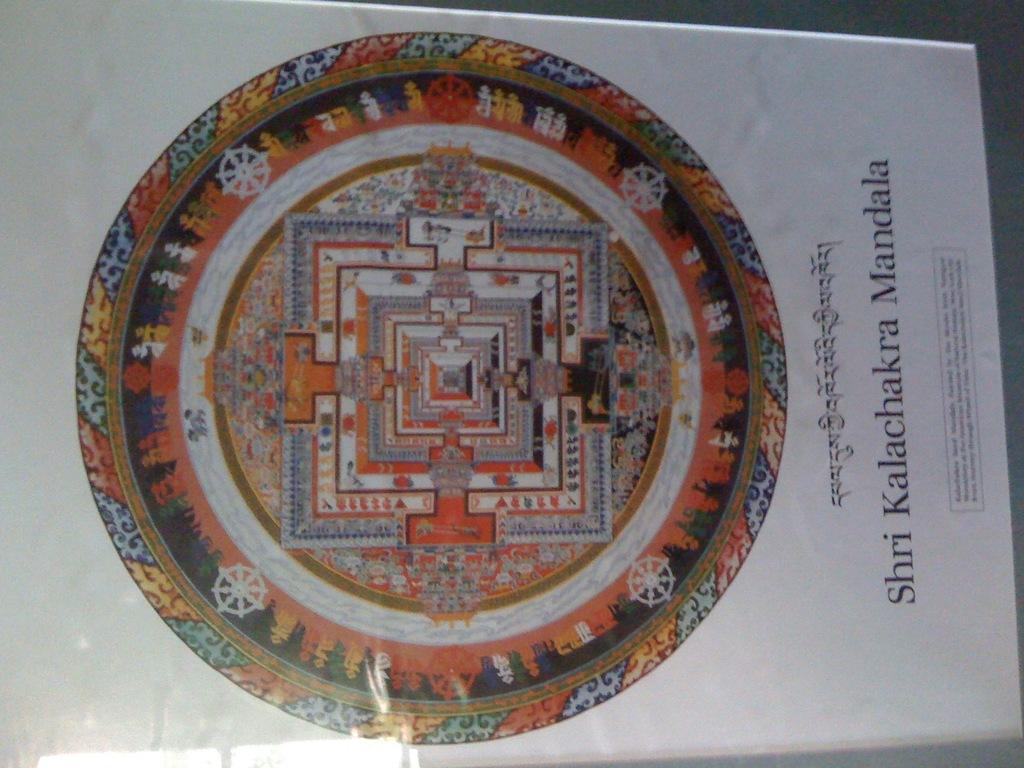What is the primary purpose of the image? The image contains information and a depiction. What is the medium of the image? The image is on a paper. What type of religion is practiced during dinner in the image? There is no reference to religion or dinner in the image, so it is not possible to answer that question. 